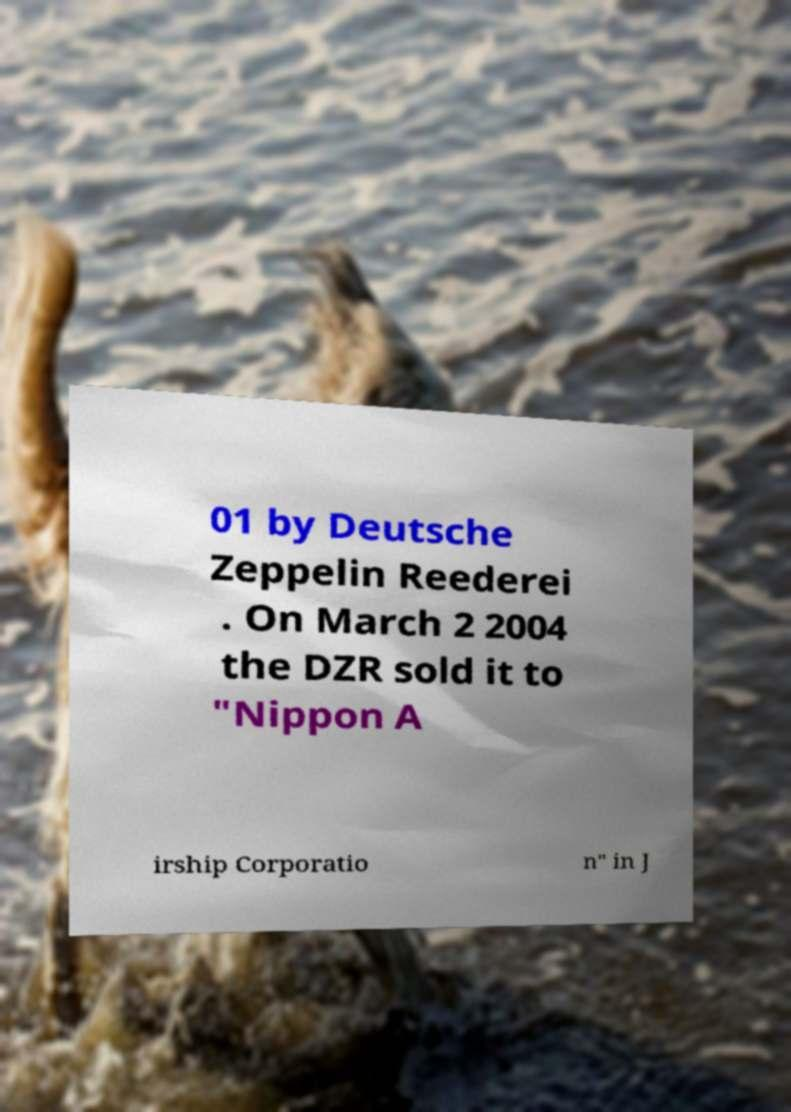Please identify and transcribe the text found in this image. 01 by Deutsche Zeppelin Reederei . On March 2 2004 the DZR sold it to "Nippon A irship Corporatio n" in J 